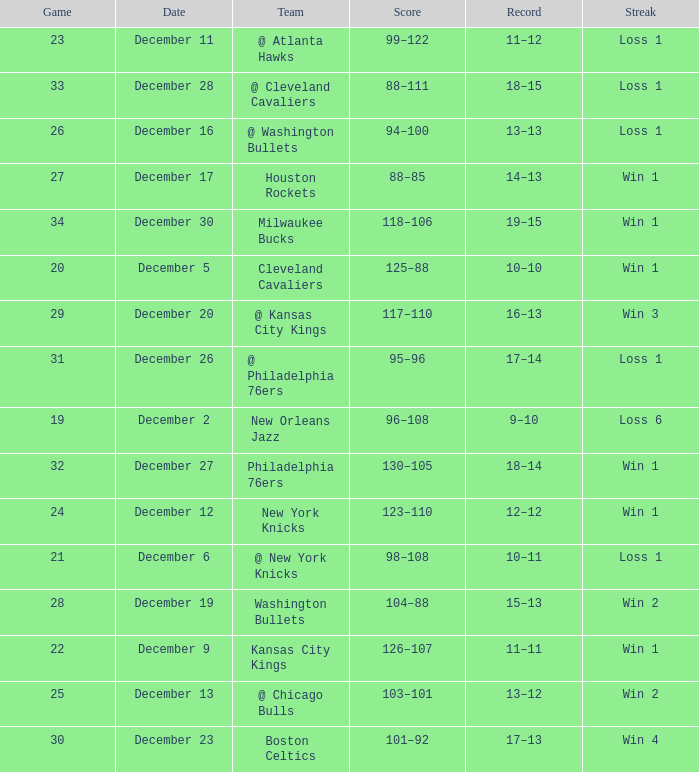What Game had a Score of 101–92? 30.0. 